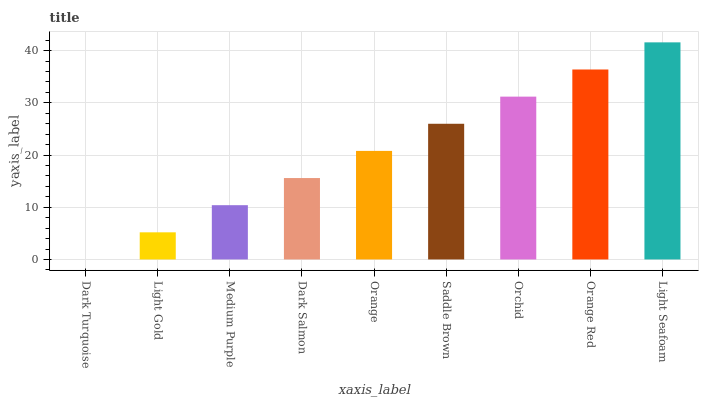Is Dark Turquoise the minimum?
Answer yes or no. Yes. Is Light Seafoam the maximum?
Answer yes or no. Yes. Is Light Gold the minimum?
Answer yes or no. No. Is Light Gold the maximum?
Answer yes or no. No. Is Light Gold greater than Dark Turquoise?
Answer yes or no. Yes. Is Dark Turquoise less than Light Gold?
Answer yes or no. Yes. Is Dark Turquoise greater than Light Gold?
Answer yes or no. No. Is Light Gold less than Dark Turquoise?
Answer yes or no. No. Is Orange the high median?
Answer yes or no. Yes. Is Orange the low median?
Answer yes or no. Yes. Is Orange Red the high median?
Answer yes or no. No. Is Dark Salmon the low median?
Answer yes or no. No. 